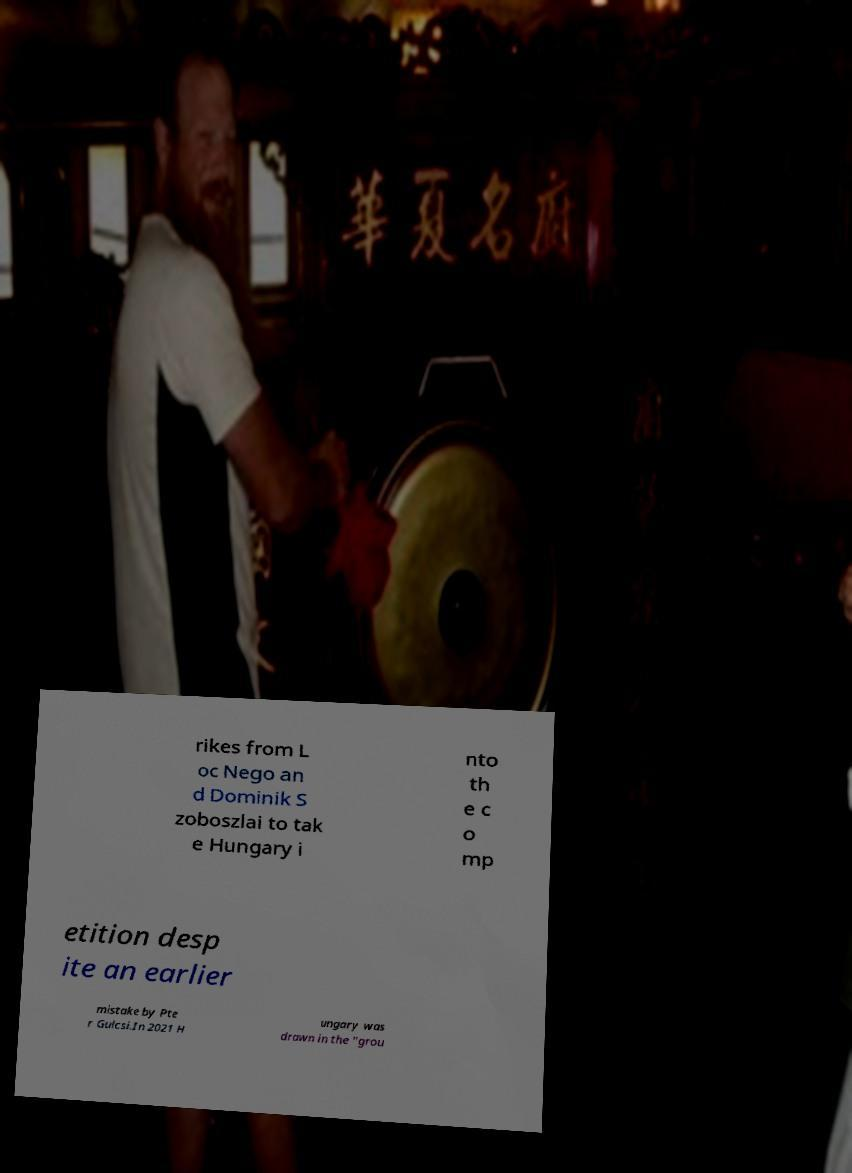Can you accurately transcribe the text from the provided image for me? rikes from L oc Nego an d Dominik S zoboszlai to tak e Hungary i nto th e c o mp etition desp ite an earlier mistake by Pte r Gulcsi.In 2021 H ungary was drawn in the "grou 